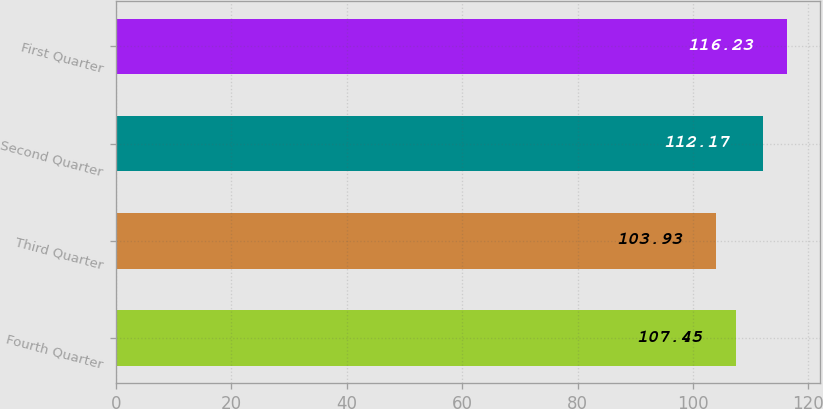<chart> <loc_0><loc_0><loc_500><loc_500><bar_chart><fcel>Fourth Quarter<fcel>Third Quarter<fcel>Second Quarter<fcel>First Quarter<nl><fcel>107.45<fcel>103.93<fcel>112.17<fcel>116.23<nl></chart> 